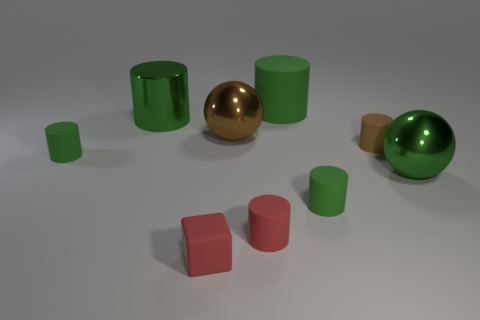What do you think the arrangement of these objects might signify? The arrangement of the objects doesn't seem to indicate any specific pattern or meaning and appears random. They may be placed to showcase contrast in forms and colors—cylinders versus spheres, green next to red and gold, creating a visual composition that emphasizes diversity in shapes and colors. Could there be a deeper meaning behind this simple composition? While the arrangement seems straightforward, it might suggest themes of individuality and uniqueness—each object reflecting differently in the light, just like individuals possess unique characteristics. Alternatively, it could be an exercise in visual balance and harmony among various geometric forms. 